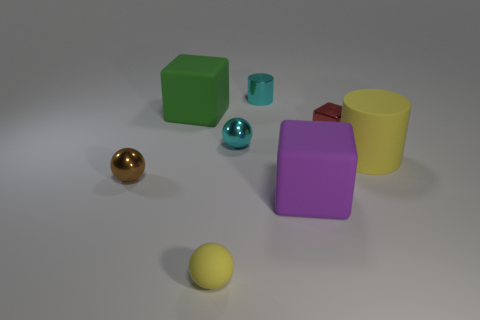Subtract all purple blocks. How many blocks are left? 2 Subtract 1 spheres. How many spheres are left? 2 Add 1 red cylinders. How many objects exist? 9 Subtract all yellow blocks. Subtract all blue balls. How many blocks are left? 3 Subtract all balls. How many objects are left? 5 Add 5 small rubber balls. How many small rubber balls are left? 6 Add 1 brown objects. How many brown objects exist? 2 Subtract 1 brown balls. How many objects are left? 7 Subtract all tiny red shiny objects. Subtract all big green matte things. How many objects are left? 6 